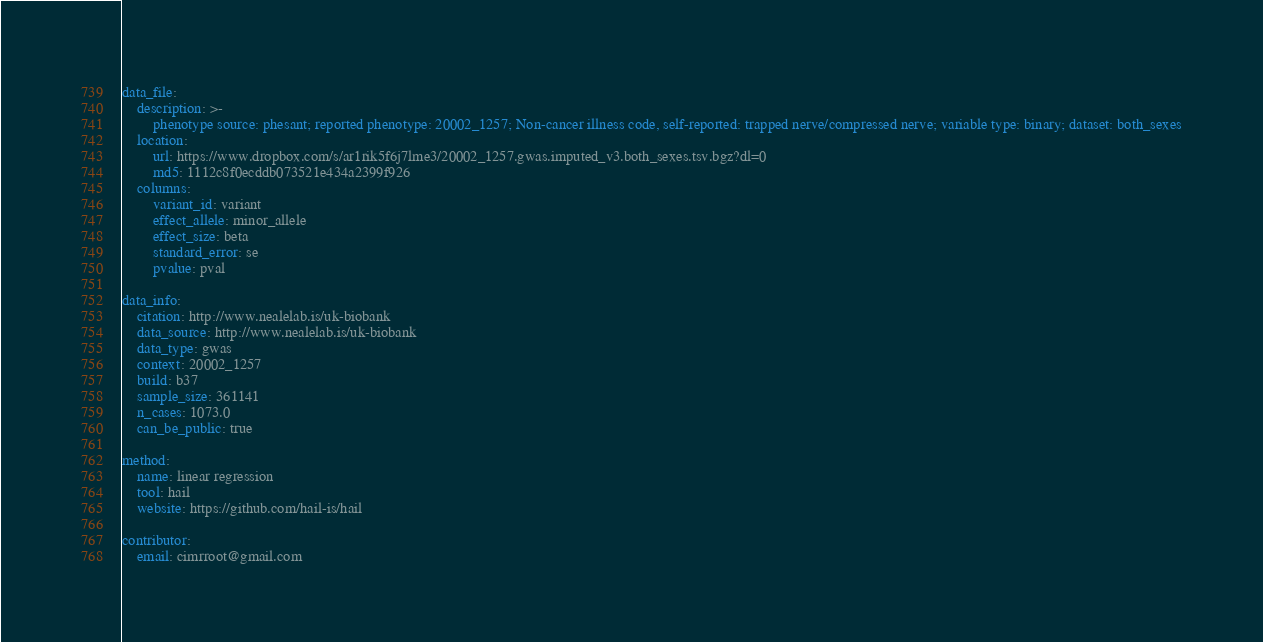Convert code to text. <code><loc_0><loc_0><loc_500><loc_500><_YAML_>
data_file:
    description: >-
        phenotype source: phesant; reported phenotype: 20002_1257; Non-cancer illness code, self-reported: trapped nerve/compressed nerve; variable type: binary; dataset: both_sexes
    location:
        url: https://www.dropbox.com/s/ar1rik5f6j7lme3/20002_1257.gwas.imputed_v3.both_sexes.tsv.bgz?dl=0
        md5: 1112c8f0ecddb073521e434a2399f926
    columns:
        variant_id: variant
        effect_allele: minor_allele
        effect_size: beta
        standard_error: se
        pvalue: pval

data_info:
    citation: http://www.nealelab.is/uk-biobank
    data_source: http://www.nealelab.is/uk-biobank
    data_type: gwas
    context: 20002_1257
    build: b37
    sample_size: 361141
    n_cases: 1073.0
    can_be_public: true

method:
    name: linear regression
    tool: hail
    website: https://github.com/hail-is/hail

contributor:
    email: cimrroot@gmail.com

</code> 